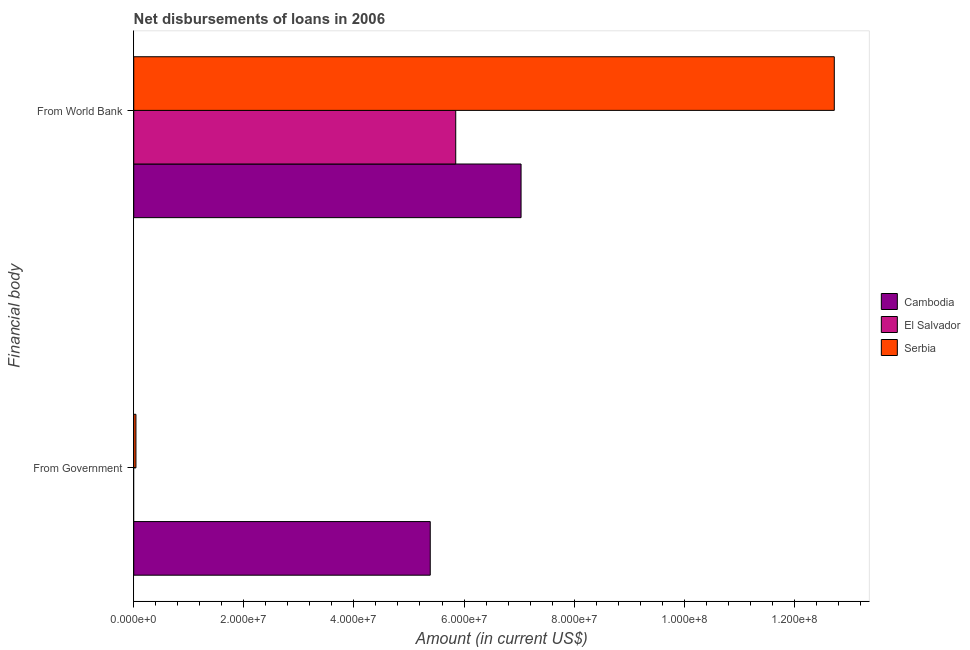How many groups of bars are there?
Give a very brief answer. 2. Are the number of bars on each tick of the Y-axis equal?
Give a very brief answer. No. How many bars are there on the 2nd tick from the top?
Provide a short and direct response. 2. How many bars are there on the 1st tick from the bottom?
Make the answer very short. 2. What is the label of the 2nd group of bars from the top?
Your answer should be compact. From Government. What is the net disbursements of loan from world bank in Serbia?
Make the answer very short. 1.27e+08. Across all countries, what is the maximum net disbursements of loan from government?
Provide a succinct answer. 5.39e+07. In which country was the net disbursements of loan from world bank maximum?
Ensure brevity in your answer.  Serbia. What is the total net disbursements of loan from world bank in the graph?
Ensure brevity in your answer.  2.56e+08. What is the difference between the net disbursements of loan from world bank in El Salvador and that in Cambodia?
Make the answer very short. -1.19e+07. What is the difference between the net disbursements of loan from government in Serbia and the net disbursements of loan from world bank in Cambodia?
Make the answer very short. -7.00e+07. What is the average net disbursements of loan from government per country?
Your answer should be compact. 1.81e+07. What is the difference between the net disbursements of loan from government and net disbursements of loan from world bank in Serbia?
Offer a terse response. -1.27e+08. In how many countries, is the net disbursements of loan from world bank greater than 96000000 US$?
Give a very brief answer. 1. What is the ratio of the net disbursements of loan from world bank in Cambodia to that in El Salvador?
Offer a very short reply. 1.2. In how many countries, is the net disbursements of loan from government greater than the average net disbursements of loan from government taken over all countries?
Give a very brief answer. 1. How many countries are there in the graph?
Provide a short and direct response. 3. Where does the legend appear in the graph?
Your answer should be compact. Center right. How are the legend labels stacked?
Offer a very short reply. Vertical. What is the title of the graph?
Your response must be concise. Net disbursements of loans in 2006. What is the label or title of the Y-axis?
Keep it short and to the point. Financial body. What is the Amount (in current US$) in Cambodia in From Government?
Offer a terse response. 5.39e+07. What is the Amount (in current US$) of El Salvador in From Government?
Give a very brief answer. 0. What is the Amount (in current US$) in Cambodia in From World Bank?
Ensure brevity in your answer.  7.04e+07. What is the Amount (in current US$) of El Salvador in From World Bank?
Offer a terse response. 5.85e+07. What is the Amount (in current US$) of Serbia in From World Bank?
Provide a succinct answer. 1.27e+08. Across all Financial body, what is the maximum Amount (in current US$) in Cambodia?
Provide a short and direct response. 7.04e+07. Across all Financial body, what is the maximum Amount (in current US$) of El Salvador?
Your response must be concise. 5.85e+07. Across all Financial body, what is the maximum Amount (in current US$) in Serbia?
Make the answer very short. 1.27e+08. Across all Financial body, what is the minimum Amount (in current US$) of Cambodia?
Keep it short and to the point. 5.39e+07. Across all Financial body, what is the minimum Amount (in current US$) in Serbia?
Ensure brevity in your answer.  4.00e+05. What is the total Amount (in current US$) of Cambodia in the graph?
Your answer should be very brief. 1.24e+08. What is the total Amount (in current US$) of El Salvador in the graph?
Offer a very short reply. 5.85e+07. What is the total Amount (in current US$) of Serbia in the graph?
Offer a terse response. 1.28e+08. What is the difference between the Amount (in current US$) of Cambodia in From Government and that in From World Bank?
Give a very brief answer. -1.65e+07. What is the difference between the Amount (in current US$) of Serbia in From Government and that in From World Bank?
Your answer should be very brief. -1.27e+08. What is the difference between the Amount (in current US$) of Cambodia in From Government and the Amount (in current US$) of El Salvador in From World Bank?
Offer a terse response. -4.63e+06. What is the difference between the Amount (in current US$) of Cambodia in From Government and the Amount (in current US$) of Serbia in From World Bank?
Ensure brevity in your answer.  -7.34e+07. What is the average Amount (in current US$) in Cambodia per Financial body?
Make the answer very short. 6.21e+07. What is the average Amount (in current US$) of El Salvador per Financial body?
Your answer should be very brief. 2.92e+07. What is the average Amount (in current US$) in Serbia per Financial body?
Your answer should be very brief. 6.38e+07. What is the difference between the Amount (in current US$) of Cambodia and Amount (in current US$) of Serbia in From Government?
Make the answer very short. 5.35e+07. What is the difference between the Amount (in current US$) in Cambodia and Amount (in current US$) in El Salvador in From World Bank?
Offer a very short reply. 1.19e+07. What is the difference between the Amount (in current US$) of Cambodia and Amount (in current US$) of Serbia in From World Bank?
Give a very brief answer. -5.69e+07. What is the difference between the Amount (in current US$) of El Salvador and Amount (in current US$) of Serbia in From World Bank?
Offer a terse response. -6.88e+07. What is the ratio of the Amount (in current US$) in Cambodia in From Government to that in From World Bank?
Keep it short and to the point. 0.77. What is the ratio of the Amount (in current US$) in Serbia in From Government to that in From World Bank?
Keep it short and to the point. 0. What is the difference between the highest and the second highest Amount (in current US$) in Cambodia?
Your answer should be compact. 1.65e+07. What is the difference between the highest and the second highest Amount (in current US$) of Serbia?
Provide a short and direct response. 1.27e+08. What is the difference between the highest and the lowest Amount (in current US$) in Cambodia?
Offer a terse response. 1.65e+07. What is the difference between the highest and the lowest Amount (in current US$) in El Salvador?
Provide a short and direct response. 5.85e+07. What is the difference between the highest and the lowest Amount (in current US$) in Serbia?
Offer a very short reply. 1.27e+08. 